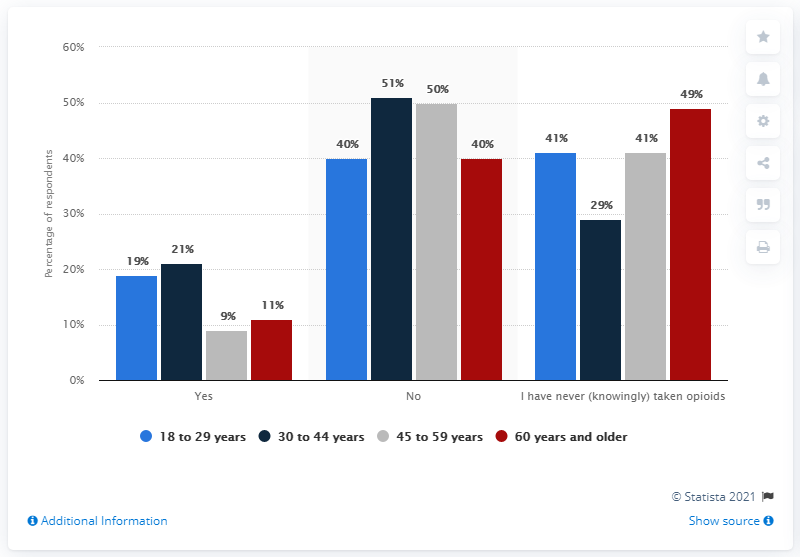Point out several critical features in this image. The highest value percentage in the red bar is 49%. The sum of all the bars in the 'yes' category is 60. 